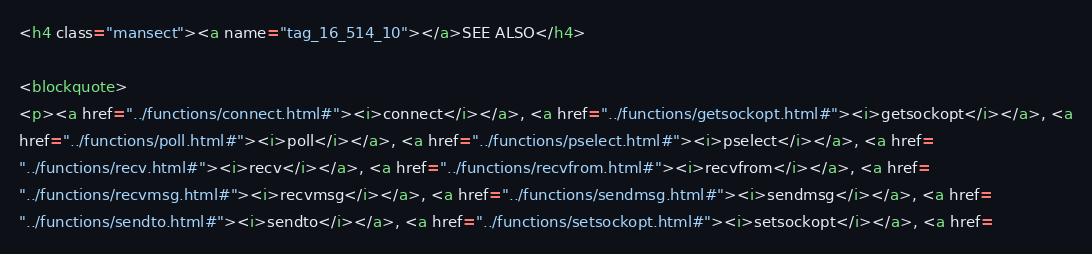<code> <loc_0><loc_0><loc_500><loc_500><_HTML_>
<h4 class="mansect"><a name="tag_16_514_10"></a>SEE ALSO</h4>

<blockquote>
<p><a href="../functions/connect.html#"><i>connect</i></a>, <a href="../functions/getsockopt.html#"><i>getsockopt</i></a>, <a
href="../functions/poll.html#"><i>poll</i></a>, <a href="../functions/pselect.html#"><i>pselect</i></a>, <a href=
"../functions/recv.html#"><i>recv</i></a>, <a href="../functions/recvfrom.html#"><i>recvfrom</i></a>, <a href=
"../functions/recvmsg.html#"><i>recvmsg</i></a>, <a href="../functions/sendmsg.html#"><i>sendmsg</i></a>, <a href=
"../functions/sendto.html#"><i>sendto</i></a>, <a href="../functions/setsockopt.html#"><i>setsockopt</i></a>, <a href=</code> 